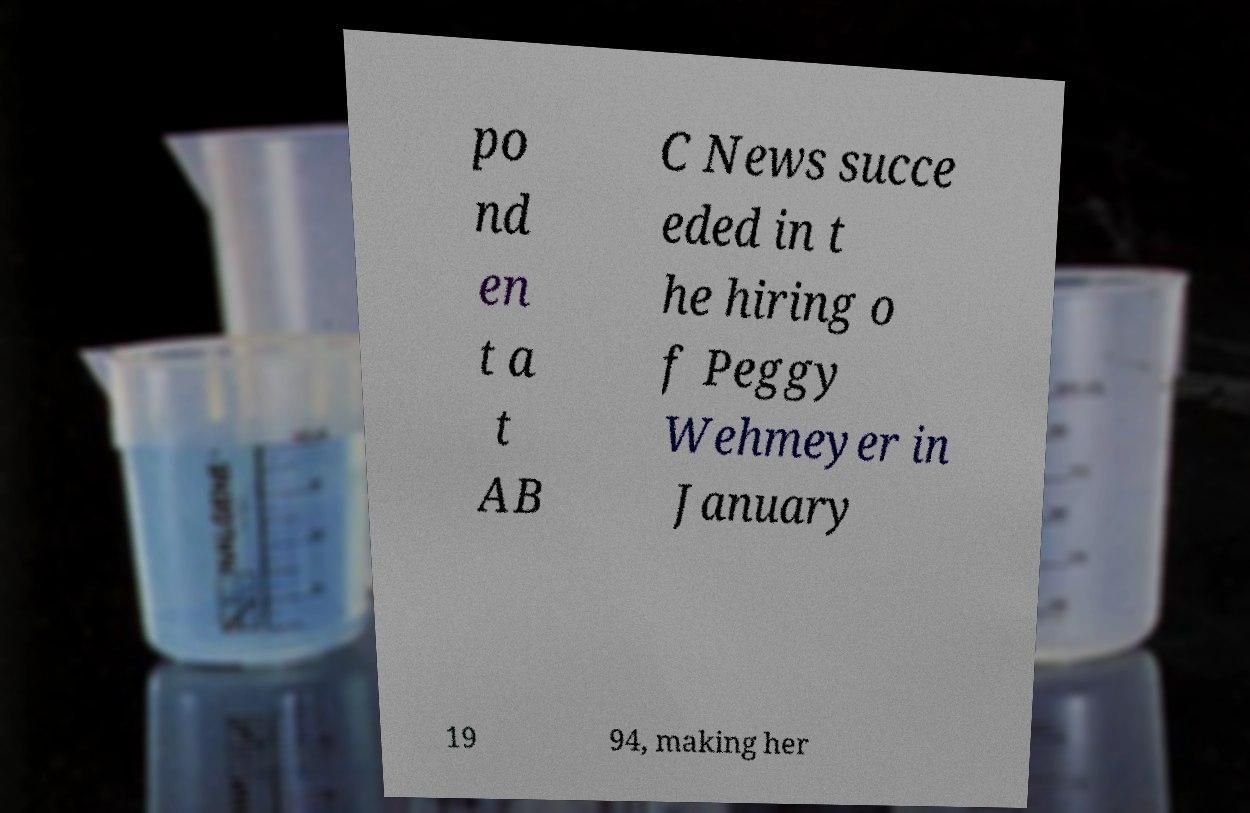Please identify and transcribe the text found in this image. po nd en t a t AB C News succe eded in t he hiring o f Peggy Wehmeyer in January 19 94, making her 